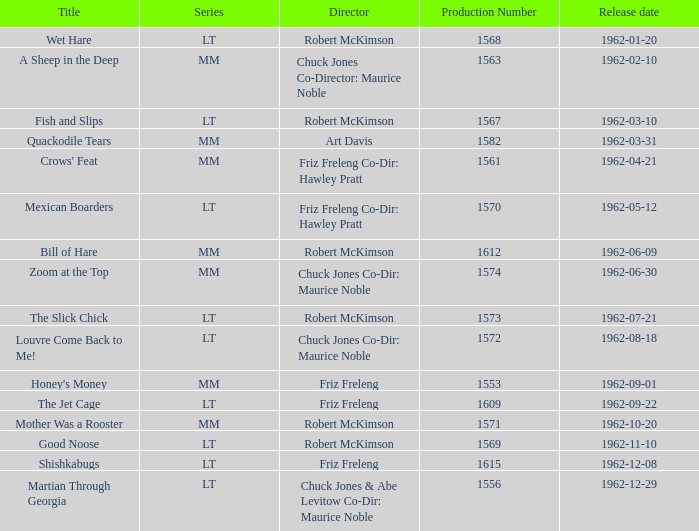What date was Wet Hare, directed by Robert McKimson, released? 1962-01-20. 